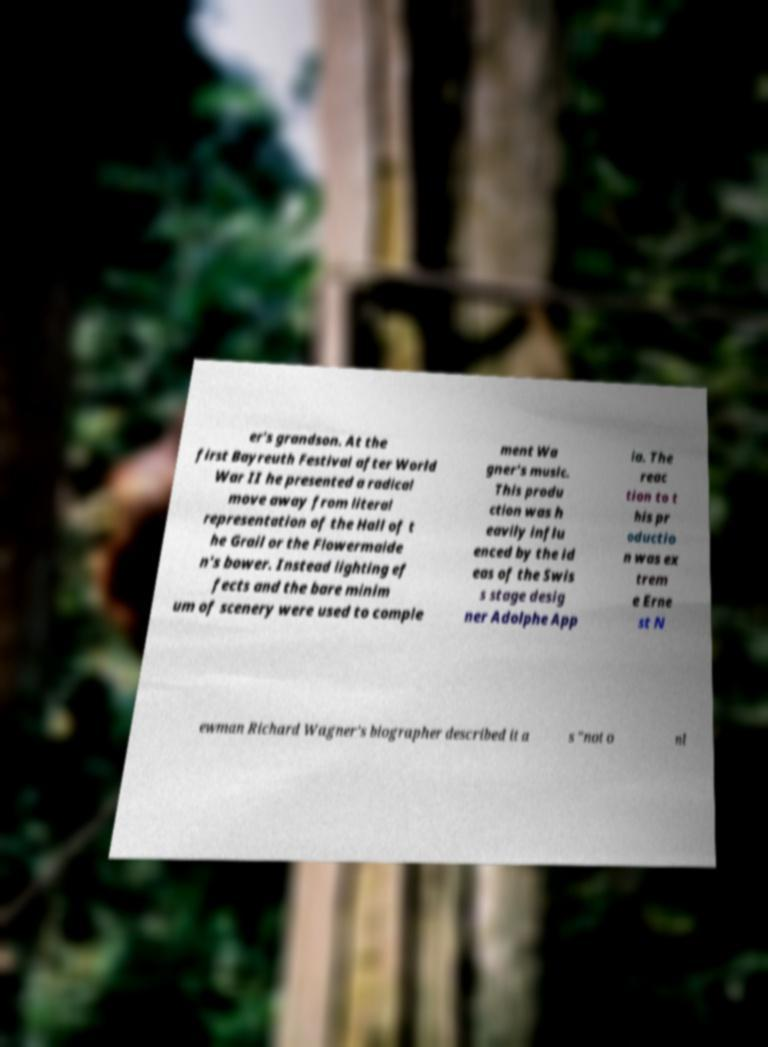Please read and relay the text visible in this image. What does it say? er's grandson. At the first Bayreuth Festival after World War II he presented a radical move away from literal representation of the Hall of t he Grail or the Flowermaide n's bower. Instead lighting ef fects and the bare minim um of scenery were used to comple ment Wa gner's music. This produ ction was h eavily influ enced by the id eas of the Swis s stage desig ner Adolphe App ia. The reac tion to t his pr oductio n was ex trem e Erne st N ewman Richard Wagner's biographer described it a s "not o nl 